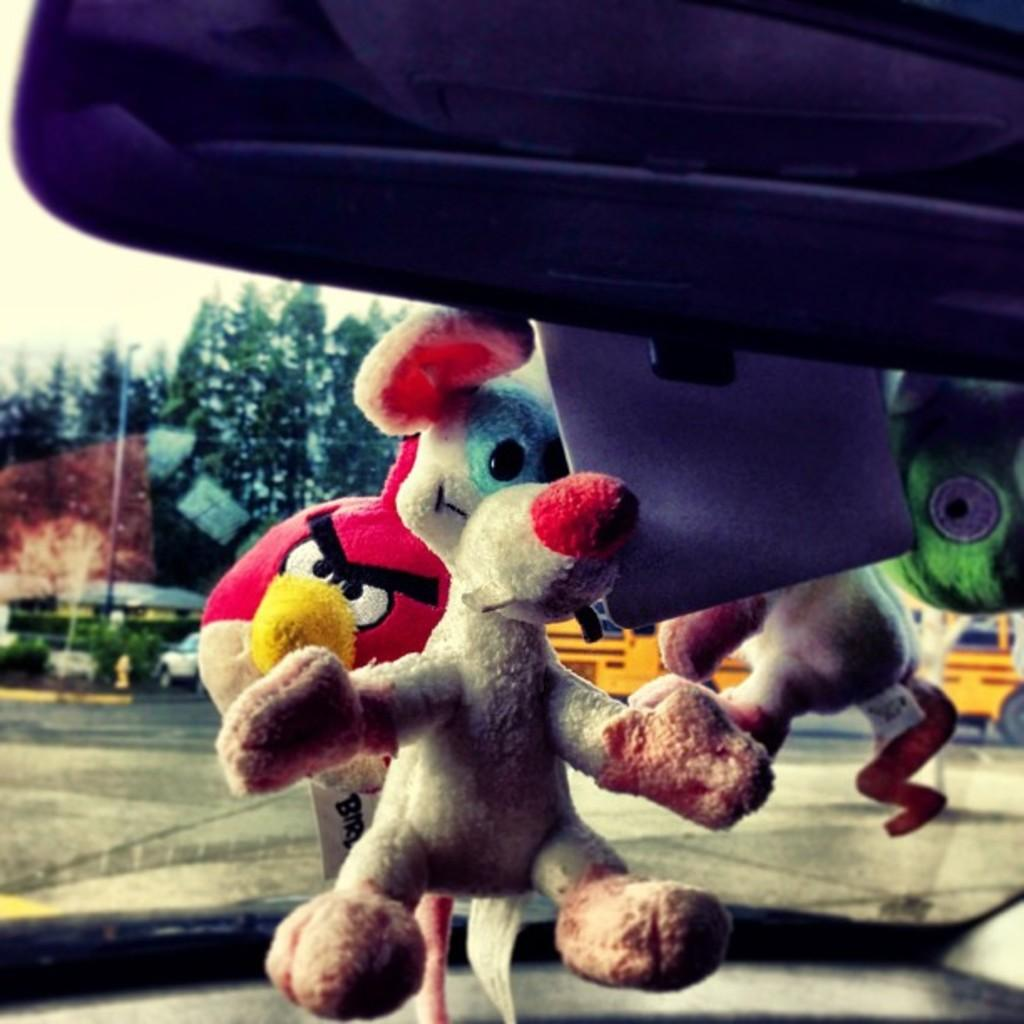What type of objects can be seen in the image? There are toys and an object visible in the image. What can be seen in the background of the image? There is a road, trees, and a pole visible in the image. What is the main mode of transportation in the image? There is a vehicle in the image. What is visible at the top of the image? The sky is visible at the top of the image. Where is the cup displayed in the image? There is no cup present in the image. What type of frame surrounds the image? The image does not depict a frame; it is a photograph or digital image. 